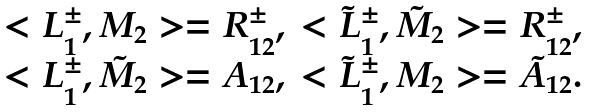<formula> <loc_0><loc_0><loc_500><loc_500>\begin{array} { c c } < L _ { 1 } ^ { \pm } , M _ { 2 } > = R _ { 1 2 } ^ { \pm } , & < \tilde { L } _ { 1 } ^ { \pm } , \tilde { M } _ { 2 } > = R _ { 1 2 } ^ { \pm } , \\ < L _ { 1 } ^ { \pm } , \tilde { M } _ { 2 } > = A _ { 1 2 } , & < \tilde { L } _ { 1 } ^ { \pm } , M _ { 2 } > = \tilde { A } _ { 1 2 } . \end{array}</formula> 